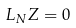<formula> <loc_0><loc_0><loc_500><loc_500>L _ { N } Z = 0</formula> 